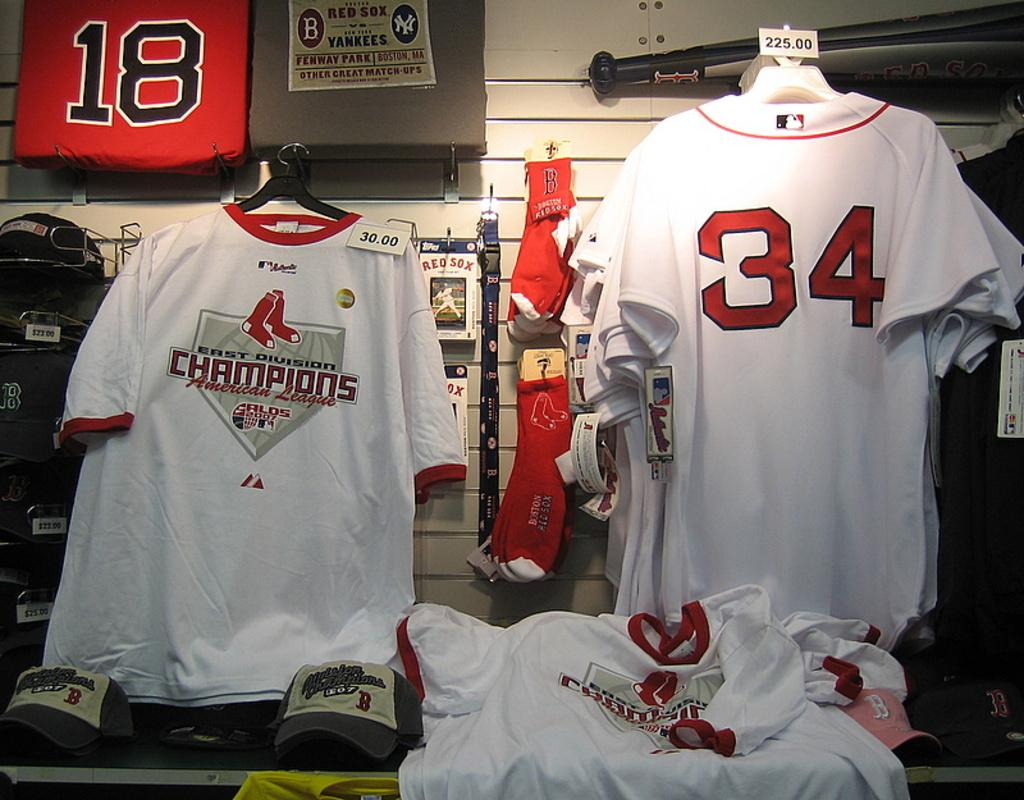<image>
Offer a succinct explanation of the picture presented. A shirt with the number 18 is displayed in a square on the wall in this shop. 